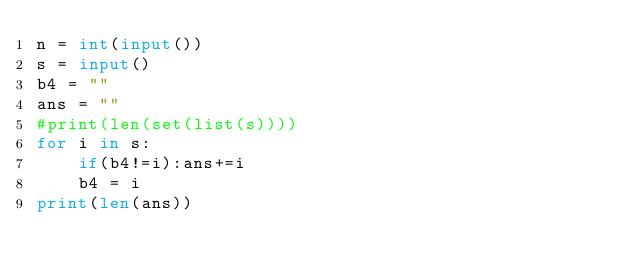Convert code to text. <code><loc_0><loc_0><loc_500><loc_500><_Python_>n = int(input())
s = input()
b4 = ""
ans = ""
#print(len(set(list(s))))
for i in s:
    if(b4!=i):ans+=i
    b4 = i
print(len(ans))</code> 